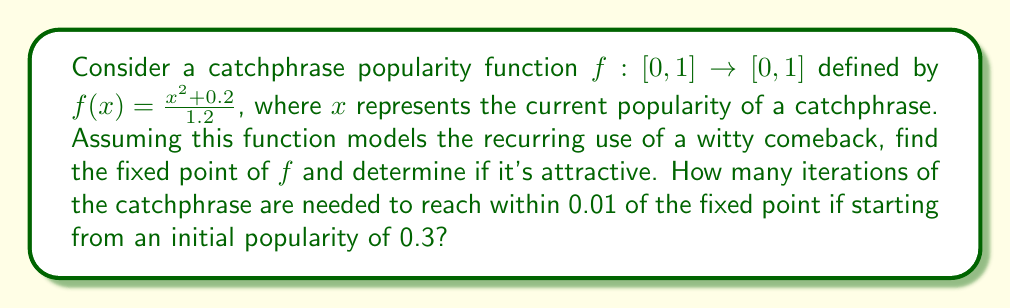Can you answer this question? 1) To find the fixed point, we solve the equation $f(x)=x$:

   $$\frac{x^2+0.2}{1.2} = x$$

2) Multiply both sides by 1.2:

   $$x^2 + 0.2 = 1.2x$$

3) Rearrange to standard quadratic form:

   $$x^2 - 1.2x + 0.2 = 0$$

4) Use the quadratic formula $x = \frac{-b \pm \sqrt{b^2-4ac}}{2a}$:

   $$x = \frac{1.2 \pm \sqrt{1.44-0.8}}{2} = \frac{1.2 \pm \sqrt{0.64}}{2} = \frac{1.2 \pm 0.8}{2}$$

5) This gives us two solutions: $x_1 = 1$ and $x_2 = 0.2$. Since $x \in [0,1]$, the fixed point is $x^* = 0.2$.

6) To check if it's attractive, we calculate $|f'(x^*)|$:

   $$f'(x) = \frac{2x}{1.2}$$
   $$|f'(0.2)| = \left|\frac{2(0.2)}{1.2}\right| = \frac{1}{3} < 1$$

   Since $|f'(x^*)| < 1$, the fixed point is attractive.

7) To find the number of iterations needed, we use the fixed-point iteration:

   $$x_{n+1} = f(x_n) = \frac{x_n^2+0.2}{1.2}$$

   Starting with $x_0 = 0.3$:

   $x_1 = f(0.3) \approx 0.2750$
   $x_2 = f(0.2750) \approx 0.2302$
   $x_3 = f(0.2302) \approx 0.2076$
   $x_4 = f(0.2076) \approx 0.2012$
   $x_5 = f(0.2012) \approx 0.2002$

8) After 5 iterations, $|x_5 - x^*| < 0.01$, so 5 iterations are needed.
Answer: 5 iterations 